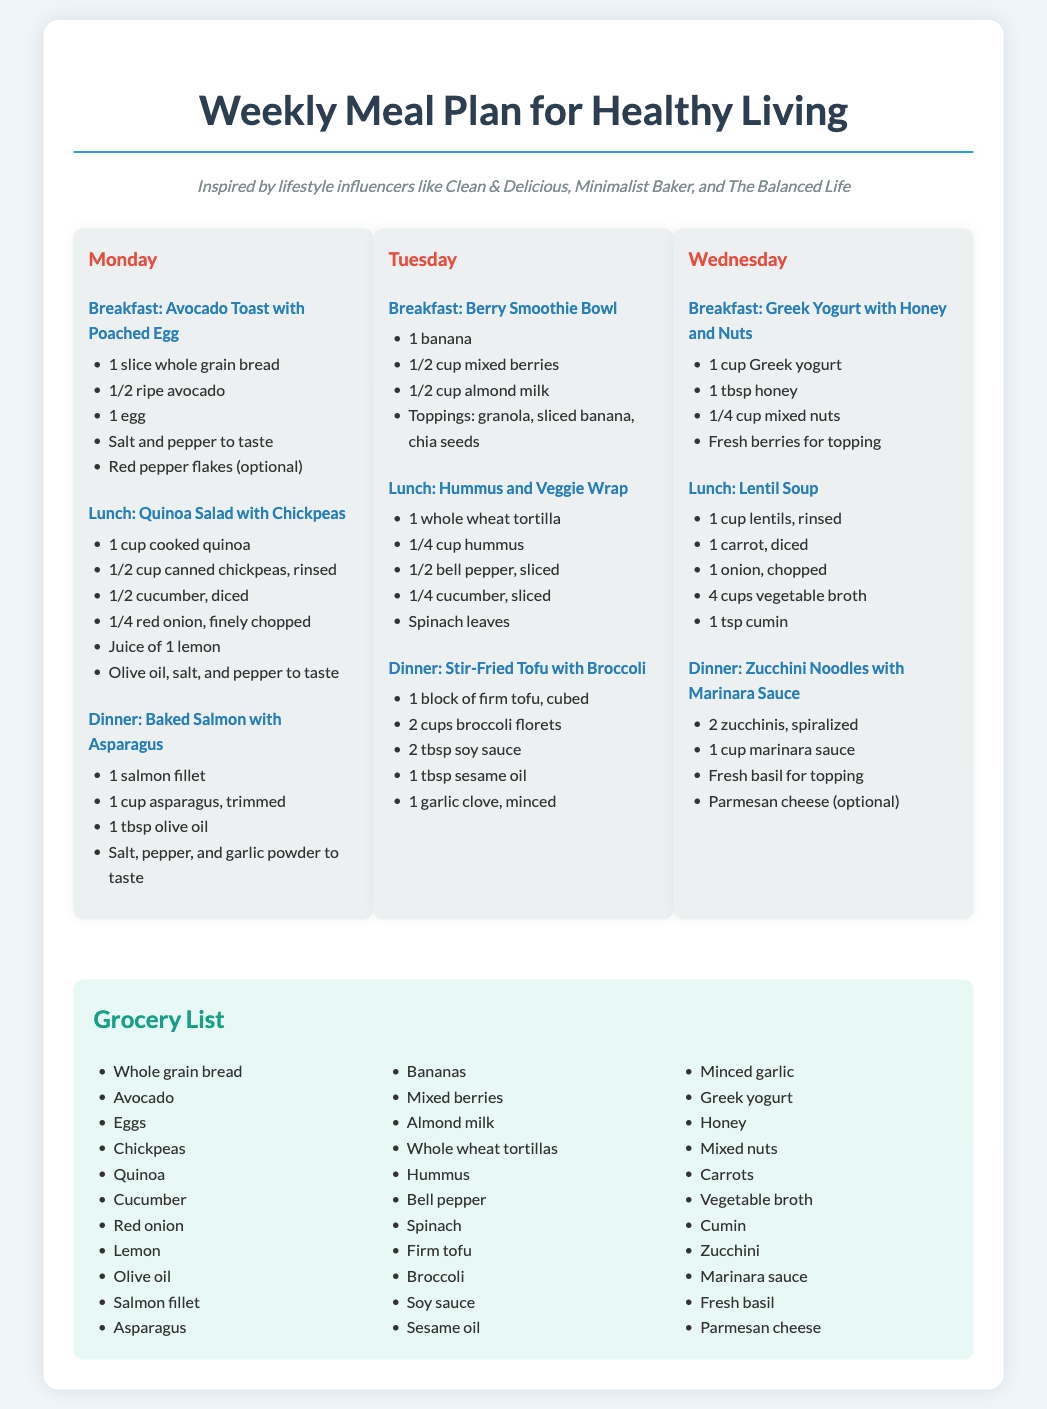What is the title of the document? The title of the document is stated at the top of the rendered content.
Answer: Weekly Meal Plan for Healthy Living Who are the lifestyle influencers mentioned? The document lists the influencers that inspired the meal plan in the introduction.
Answer: Clean & Delicious, Minimalist Baker, and The Balanced Life What is the breakfast for Tuesday? The specific meal for Tuesday breakfast can be found under the Tuesday section.
Answer: Berry Smoothie Bowl How many meals are listed for Monday? The document states the number of meals provided for each day, specifically for Monday.
Answer: 3 What is one of the ingredients for the Baked Salmon with Asparagus? The ingredients can be found listed under the Dinner section for Monday.
Answer: Salmon fillet How many cups of vegetable broth are needed for the Lentil Soup? The amount of vegetable broth is mentioned in the ingredients for the Lentil Soup.
Answer: 4 cups Which meal includes Greek yogurt? This meal can be found in the breakfast section for Wednesday.
Answer: Greek Yogurt with Honey and Nuts What is one option for toppings on the Berry Smoothie Bowl? Toppings are listed in the breakfast section for Tuesday.
Answer: Granola 